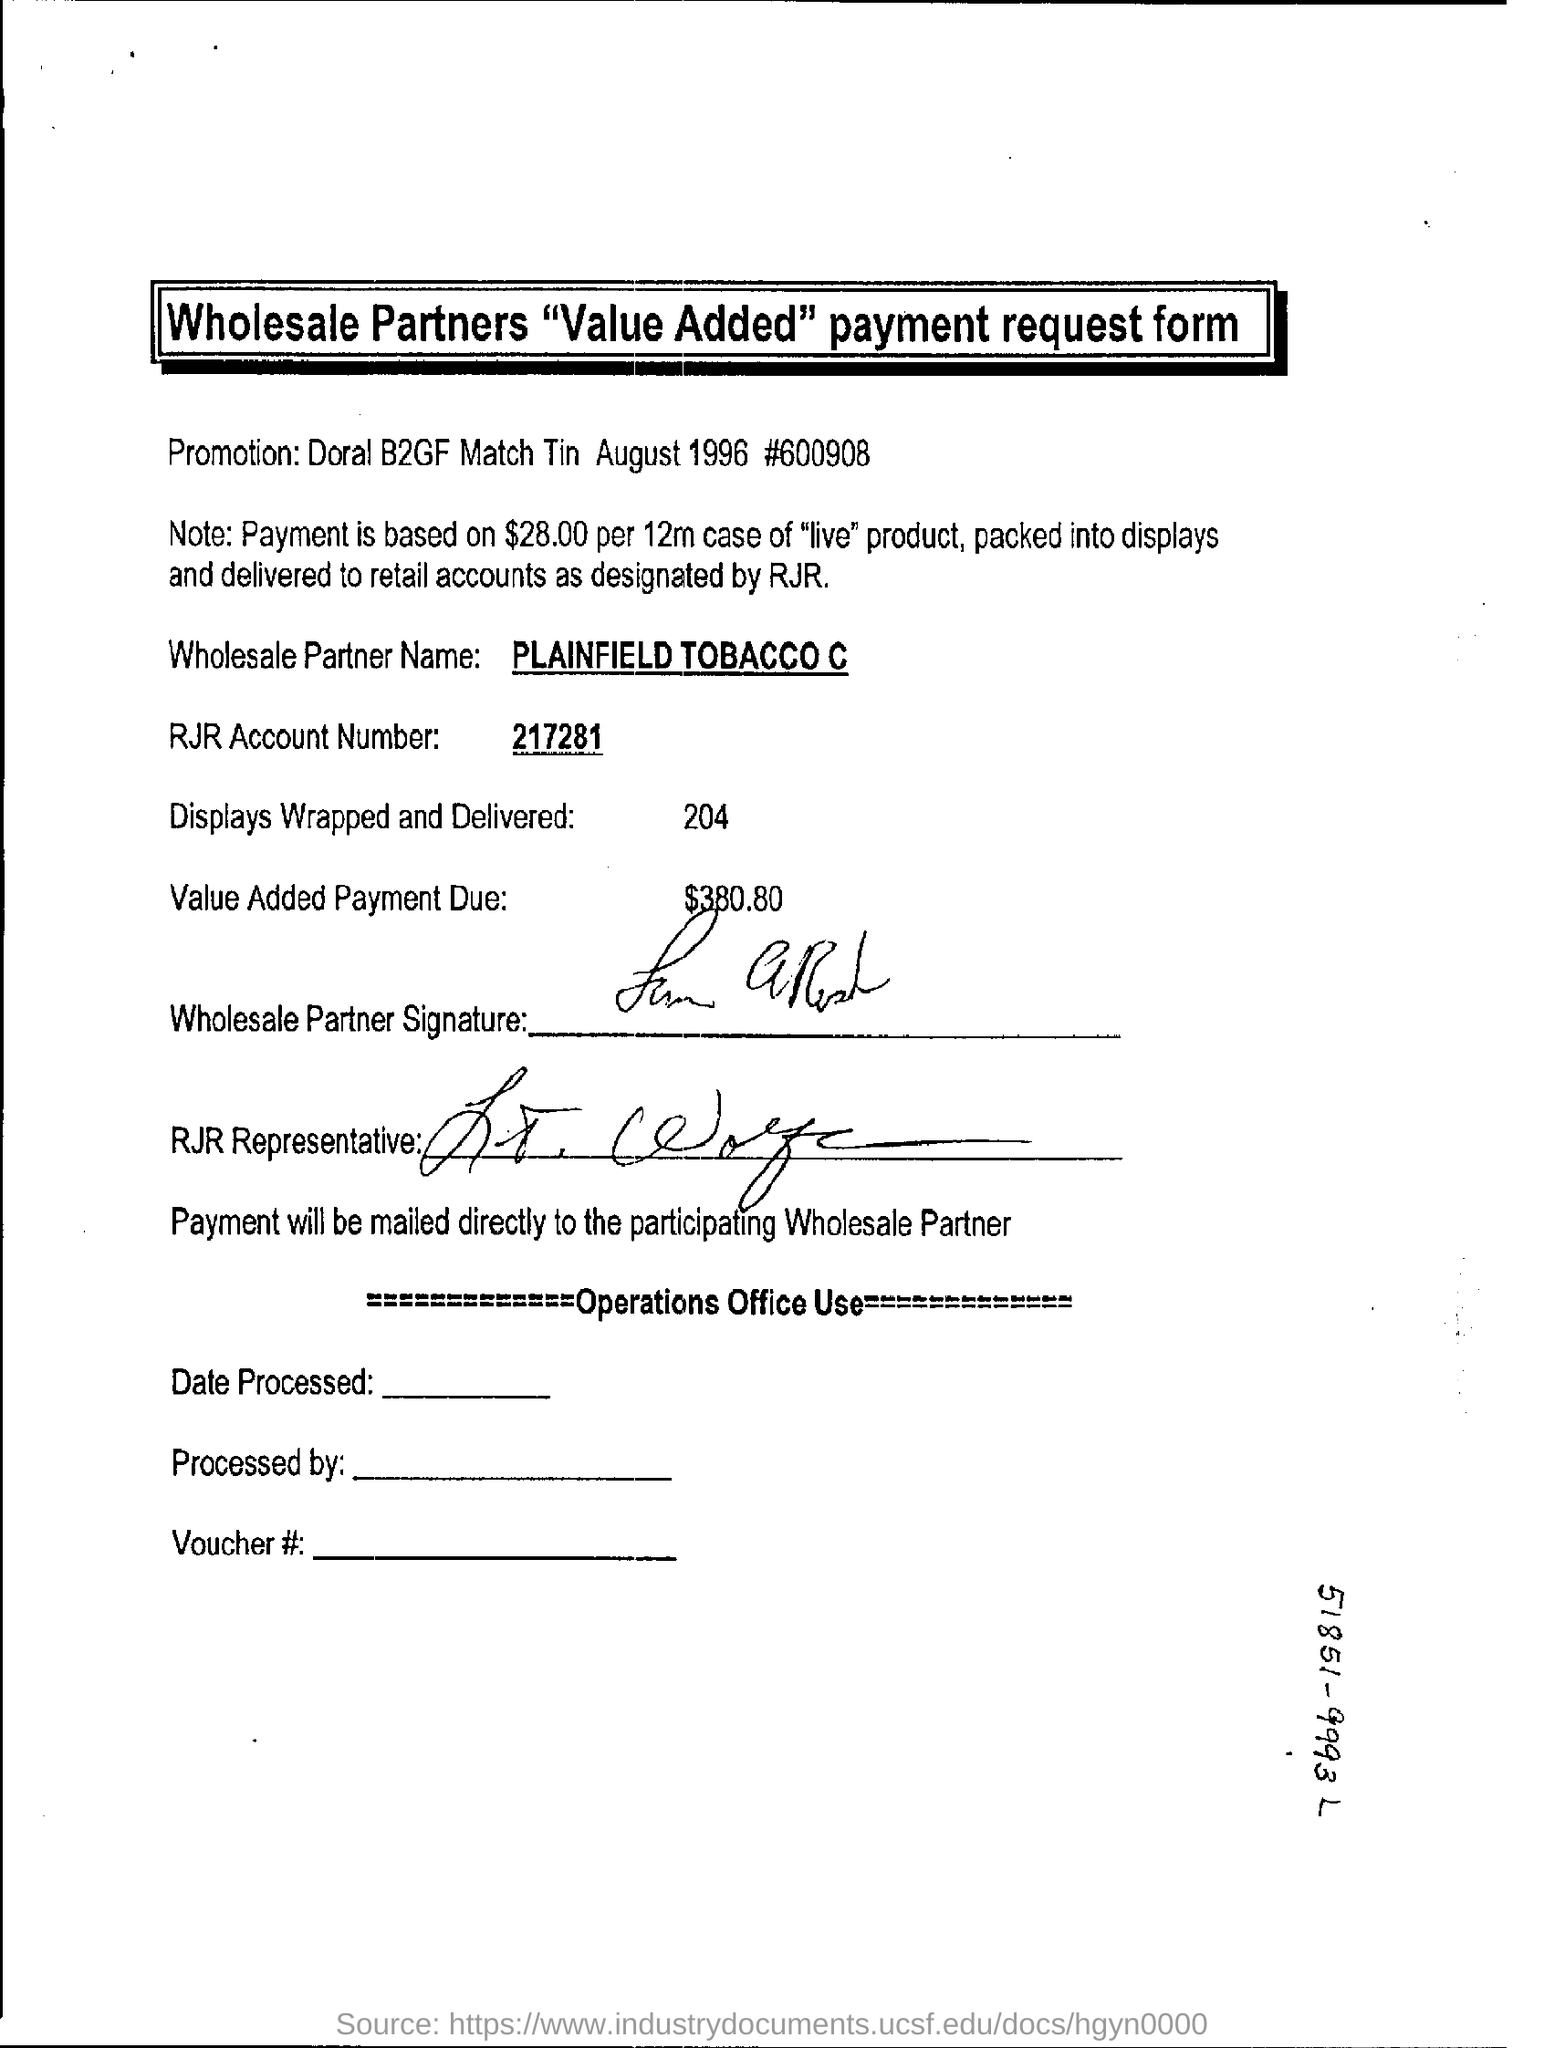How many displays are wrapped and delivered?
Give a very brief answer. 204. What is the number 217281 referring to?
Give a very brief answer. RJR Account Number. What is the wholesale partner name?
Provide a short and direct response. PLAINFIELD TOBACCO C. What is the RJR account no given?
Make the answer very short. 217281. 